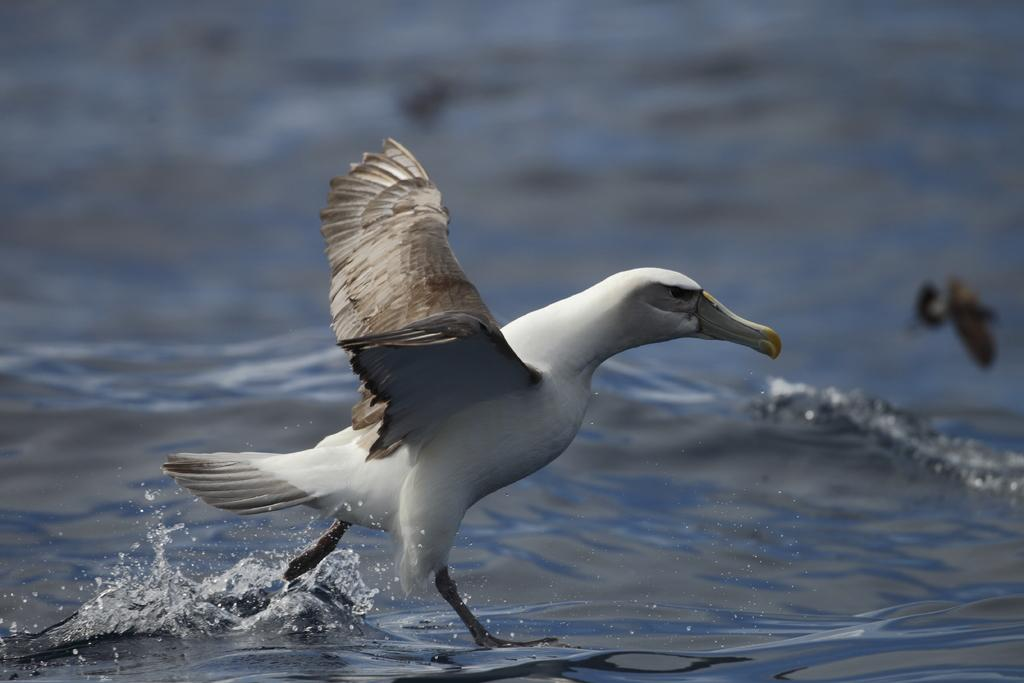What type of animal can be seen in the image? There is a bird in the image. Where is the bird located in the image? The bird is standing on the water. What type of poison is the bird using to protect itself in the image? There is no mention of poison in the image; the bird is simply standing on the water. 